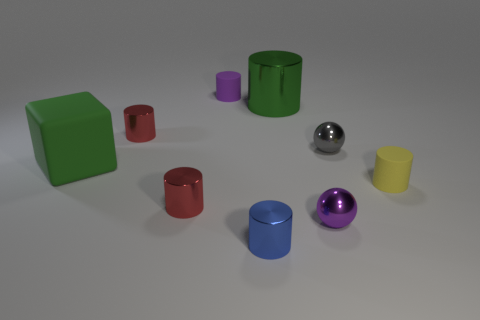How many cylinders are both on the right side of the gray sphere and behind the gray shiny object?
Offer a terse response. 0. What material is the tiny red object that is behind the small matte thing that is in front of the purple rubber cylinder?
Offer a terse response. Metal. What is the material of the purple object that is the same shape as the small yellow rubber thing?
Offer a terse response. Rubber. Are any large gray shiny things visible?
Give a very brief answer. No. There is a yellow object that is made of the same material as the purple cylinder; what is its shape?
Keep it short and to the point. Cylinder. There is a purple thing that is right of the small purple cylinder; what is it made of?
Make the answer very short. Metal. Does the large object in front of the large cylinder have the same color as the large cylinder?
Your answer should be compact. Yes. What is the size of the green block on the left side of the tiny rubber object that is right of the tiny purple metal thing?
Your answer should be compact. Large. Are there more tiny cylinders behind the small purple ball than tiny yellow cylinders?
Make the answer very short. Yes. There is a blue cylinder right of the matte block; is it the same size as the small purple metallic sphere?
Offer a very short reply. Yes. 